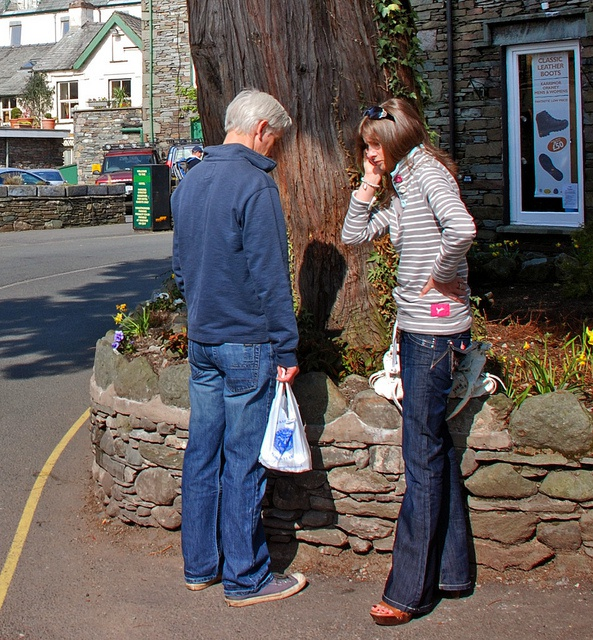Describe the objects in this image and their specific colors. I can see people in darkgray, darkblue, gray, navy, and blue tones, people in darkgray, black, navy, and lightgray tones, handbag in darkgray, gray, black, maroon, and purple tones, truck in darkgray, gray, blue, brown, and black tones, and handbag in darkgray, white, lightpink, and gray tones in this image. 